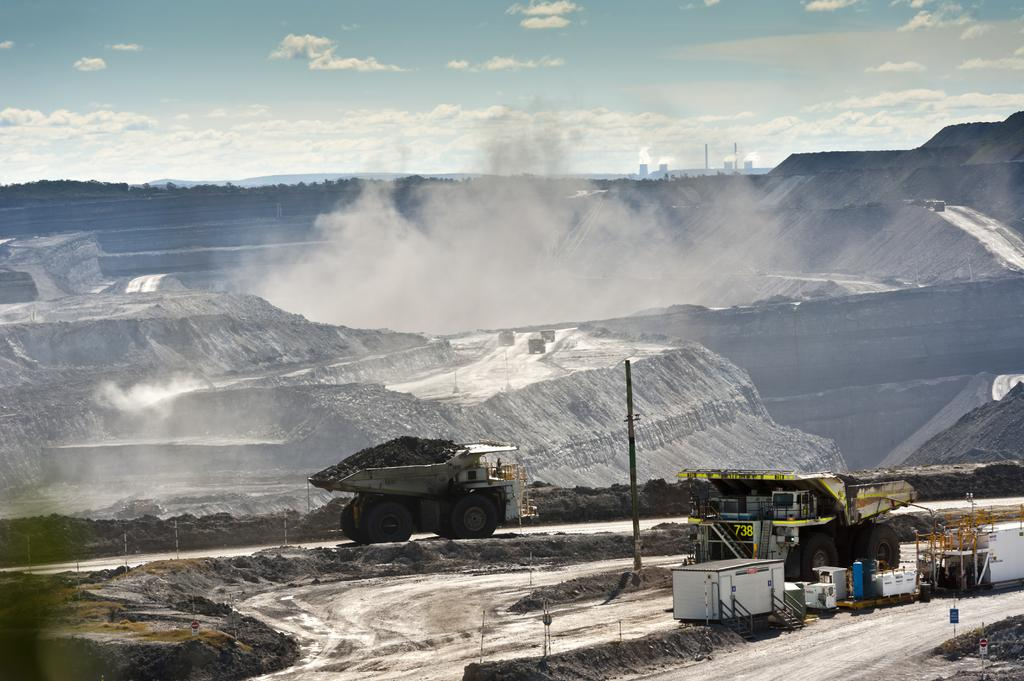What type of vehicles can be seen in the image? There are trucks in the image. What structures are present in the image? There are poles in the image. What is the main feature of the setting in the image? There is a road in the image. What type of markings are visible in the image? Numbers are written in the image. What can be seen in the background of the image? There is smoke, clouds, and the sky visible in the background of the image. Where is the table located in the image? There is no table present in the image. What type of wilderness can be seen in the background of the image? There is no wilderness visible in the image; it features a road, trucks, poles, numbers, smoke, clouds, and the sky. 